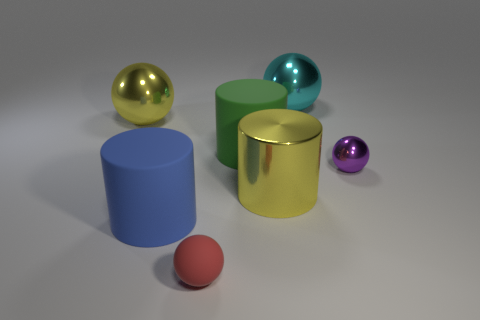Are there any large cyan metal things of the same shape as the purple metal thing?
Keep it short and to the point. Yes. What number of objects are either large cyan metallic objects or large metallic objects on the left side of the purple ball?
Keep it short and to the point. 3. What number of other objects are there of the same material as the big blue cylinder?
Offer a very short reply. 2. What number of things are either large blue cylinders or small gray metallic cylinders?
Give a very brief answer. 1. Is the number of green cylinders that are in front of the large green matte cylinder greater than the number of purple spheres that are in front of the tiny red sphere?
Your response must be concise. No. Do the big shiny object to the left of the green thing and the big metal thing in front of the large green matte object have the same color?
Give a very brief answer. Yes. How big is the metallic cylinder that is on the left side of the small purple metal ball that is in front of the matte cylinder that is behind the blue rubber cylinder?
Your answer should be very brief. Large. There is a large metallic thing that is the same shape as the blue matte object; what color is it?
Your answer should be very brief. Yellow. Is the number of small balls on the right side of the cyan ball greater than the number of blue balls?
Your answer should be very brief. Yes. Do the red matte object and the yellow thing to the left of the matte sphere have the same shape?
Your answer should be very brief. Yes. 